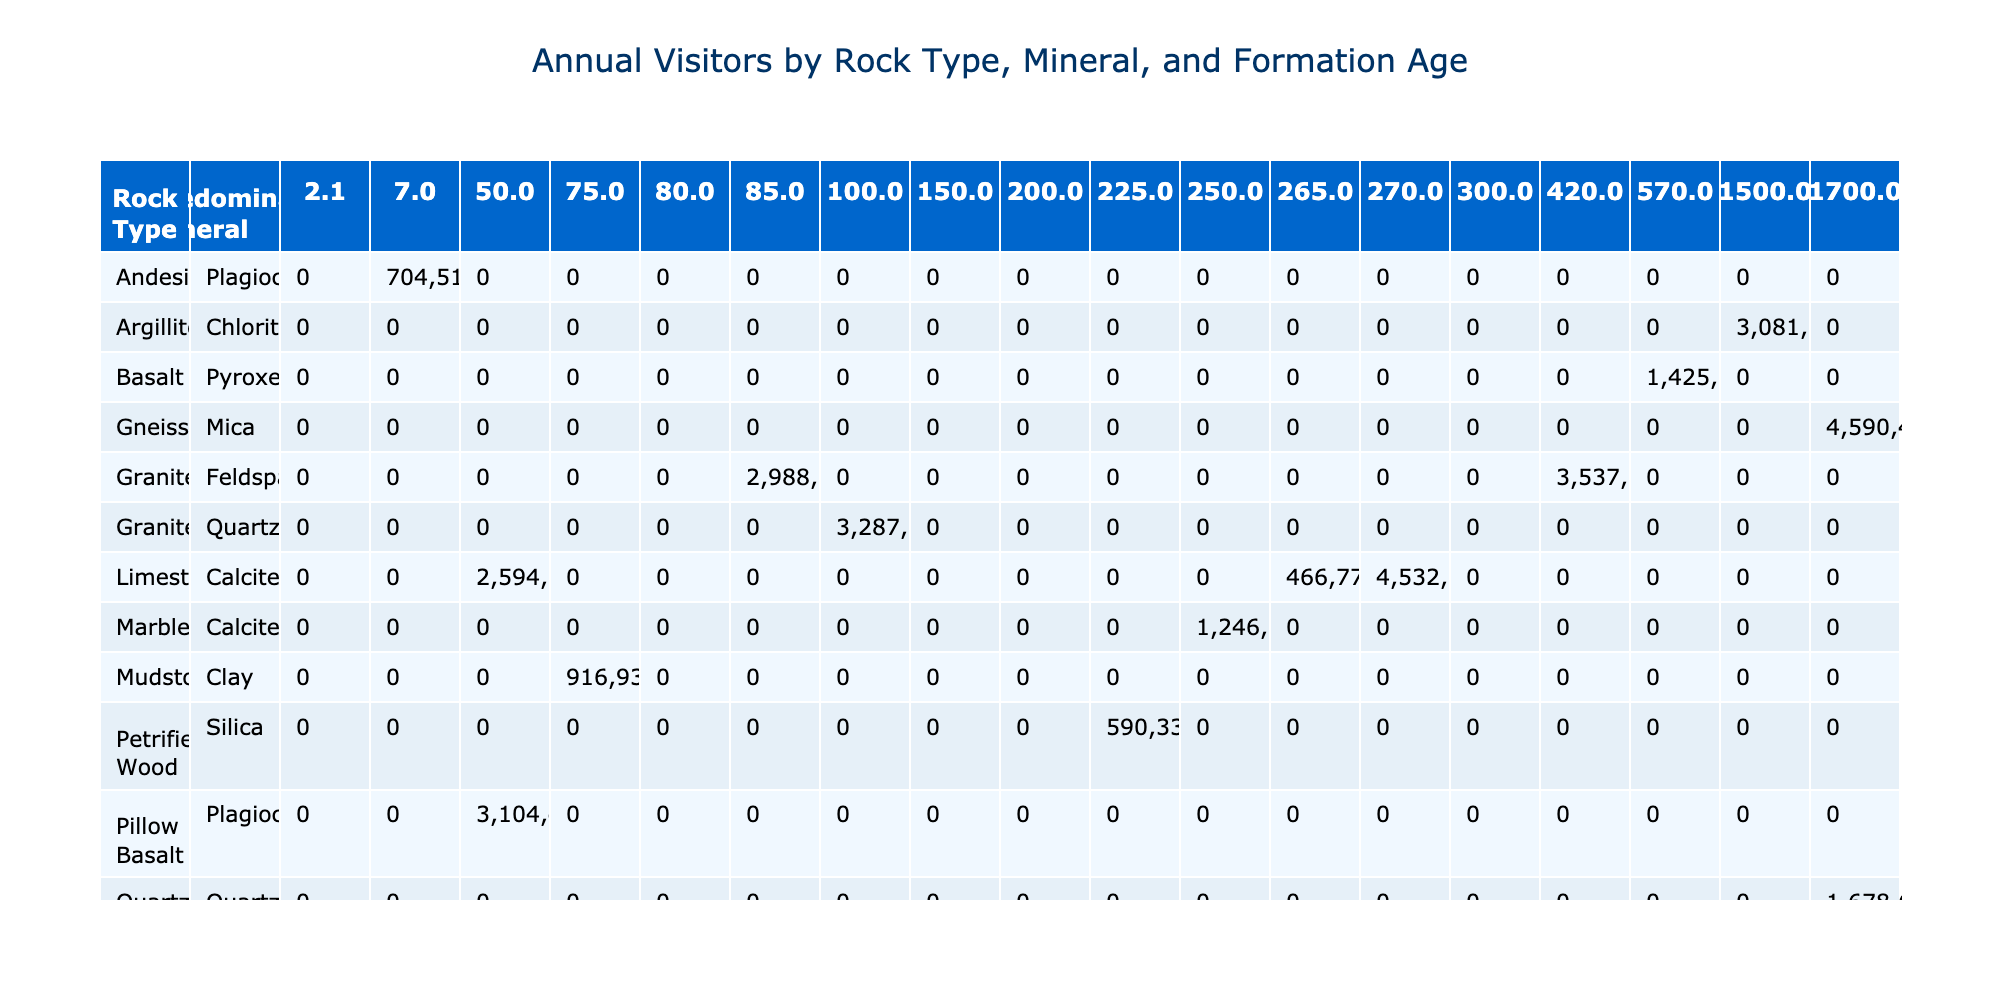What rock type has the highest number of annual visitors? By scanning through the "Annual Visitors" column in the table, I see that Rocky Mountain National Park, which has Gneiss rock type, has the highest value with 4,590,493 annual visitors.
Answer: Gneiss Which predominant mineral is associated with the oldest rock formation age? The oldest formation age in the table is listed under Gneiss, which has a formation age of 1,700 million years. The predominant mineral for this rock type is Mica.
Answer: Mica What is the total number of annual visitors for parks that primarily have Sandstone? For the parks with Sandstone (Zion National Park, Arches National Park, and Mesa Verde National Park), the annual visitors are 3,591,254 + 1,659,702 + 563,420 = 5,814,376.
Answer: 5814376 Is the predominant mineral Feldspar found in any rock type with a formation age greater than 100 million years? By analyzing the data, Feldspar is associated with Granite in Joshua Tree National Park which has a formation age of 85 million years. There are no instances of Feldspar with greater than 100 million years, so the answer is no.
Answer: No Which rock type has the least number of annual visitors and what is that number? Scanning the data, the rock type with the least number of annual visitors is Mudstone from Badlands National Park, which has 916,932 visitors.
Answer: 916932 What is the average formation age of rock types classified as Limestone? The formation ages for Limestone (270, 50, 265 million years) need to be summed up: 270 + 50 + 265 = 585. There are three parks, so average is 585 / 3 = 195 million years.
Answer: 195 Which park has the highest elevation and what rock type does it feature? By reviewing the "Elevation" column, Rocky Mountain National Park has the highest elevation at 3,400 meters and features Gneiss rock type.
Answer: Gneiss, 3400 meters What percentage of annual visitors does Yellowstone National Park contribute compared to all parks listed? Yellowstone National Park has 4,086,890 annual visitors. Adding all parks gives a total of 20,846,316 visitors. The percentage is (4,086,890 / 20,846,316) * 100 = approximately 19.6%.
Answer: 19.6% 